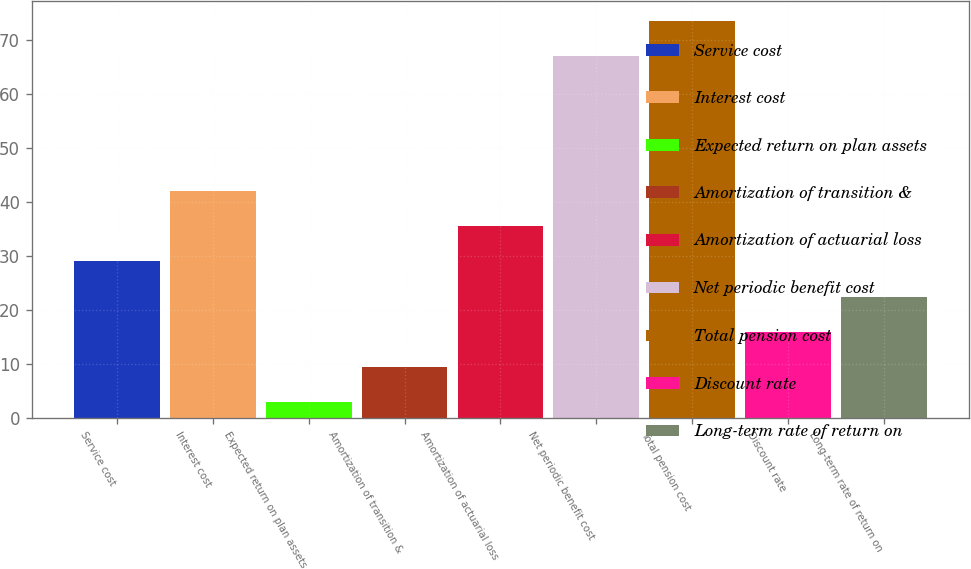<chart> <loc_0><loc_0><loc_500><loc_500><bar_chart><fcel>Service cost<fcel>Interest cost<fcel>Expected return on plan assets<fcel>Amortization of transition &<fcel>Amortization of actuarial loss<fcel>Net periodic benefit cost<fcel>Total pension cost<fcel>Discount rate<fcel>Long-term rate of return on<nl><fcel>29<fcel>42<fcel>3<fcel>9.5<fcel>35.5<fcel>67<fcel>73.5<fcel>16<fcel>22.5<nl></chart> 